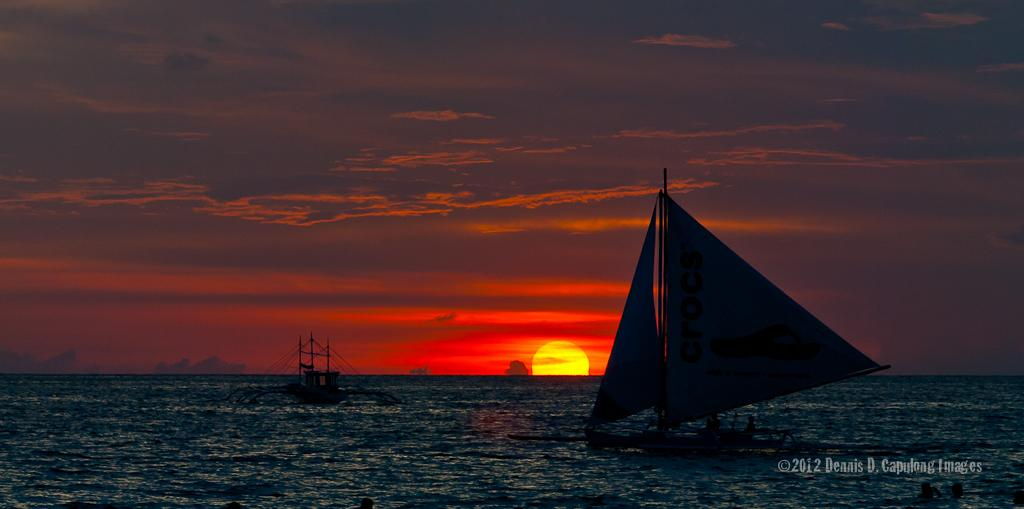What is the main subject of the image? The main subject of the image is the beautiful view of the sunset sky. What is located in the water in the front of the image? There is a small boat in the water in the front of the image. What color is the sky in the image? The sky in the image is orange. Can you see the sun in the sky? Yes, the sun is visible in the sky. What type of education is being provided in the image? There is no indication of any educational activity in the image; it features a beautiful sunset sky with a small boat in the water. Can you see an umbrella in the image? There is no umbrella present in the image. 